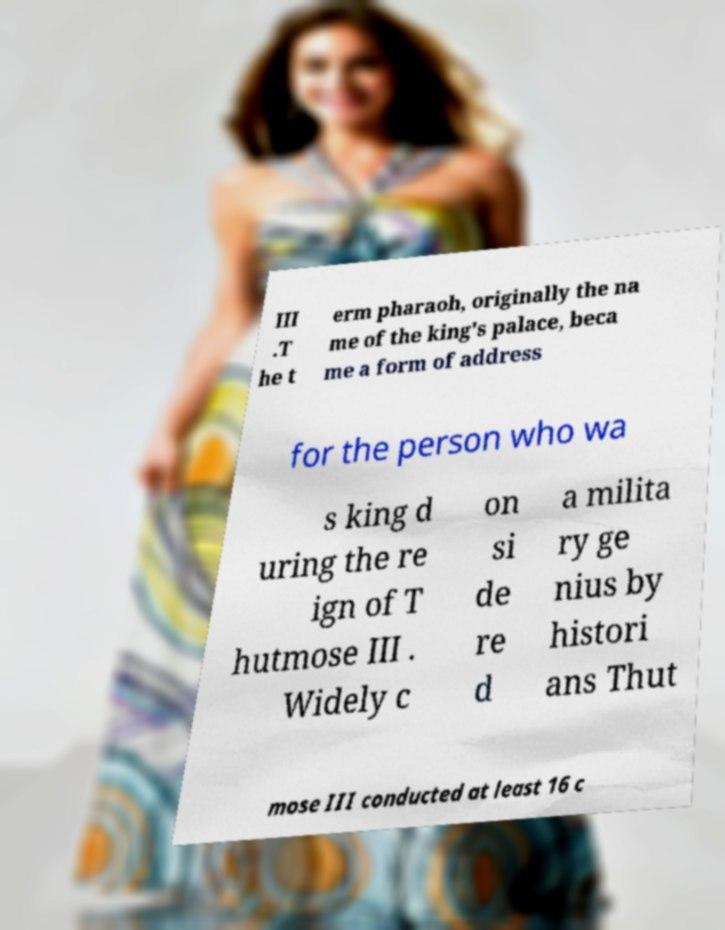Can you read and provide the text displayed in the image?This photo seems to have some interesting text. Can you extract and type it out for me? III .T he t erm pharaoh, originally the na me of the king's palace, beca me a form of address for the person who wa s king d uring the re ign of T hutmose III . Widely c on si de re d a milita ry ge nius by histori ans Thut mose III conducted at least 16 c 